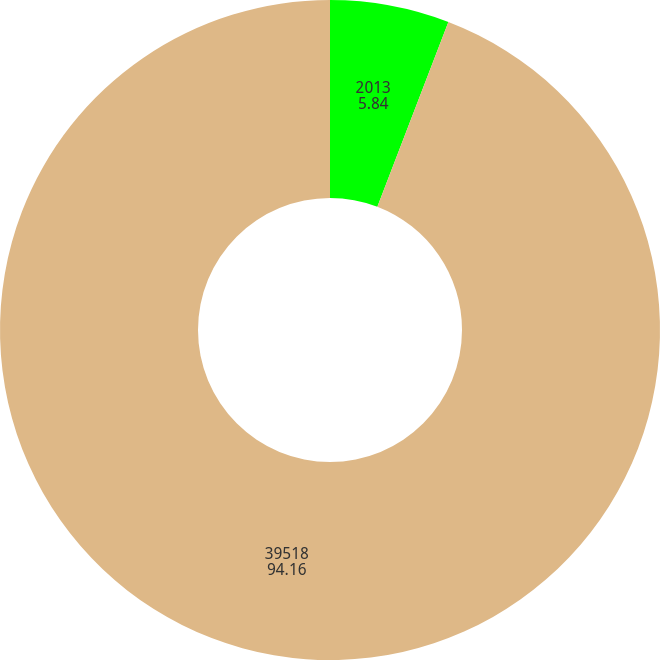Convert chart. <chart><loc_0><loc_0><loc_500><loc_500><pie_chart><fcel>2013<fcel>39518<nl><fcel>5.84%<fcel>94.16%<nl></chart> 